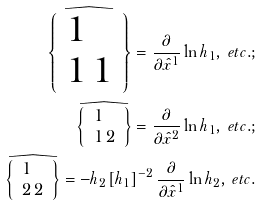<formula> <loc_0><loc_0><loc_500><loc_500>\widehat { \left \{ \begin{array} { l } 1 \\ 1 \, 1 \end{array} \right \} } = \frac { \partial } { \partial \hat { x } ^ { 1 } } \ln h _ { 1 } , \, e t c . ; \\ \widehat { \left \{ \begin{array} { l } 1 \\ 1 \, 2 \end{array} \right \} } = \frac { \partial } { \partial \hat { x } ^ { 2 } } \ln h _ { 1 } , \, e t c . ; \\ \widehat { \left \{ \begin{array} { l } 1 \\ 2 \, 2 \end{array} \right \} } = - h _ { 2 } \left [ h _ { 1 } \right ] ^ { - 2 } \frac { \partial } { \partial \hat { x } ^ { 1 } } \ln h _ { 2 } , \, e t c .</formula> 